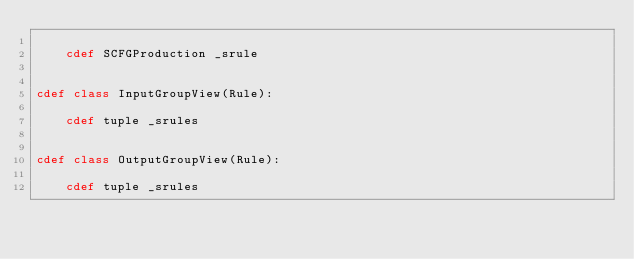Convert code to text. <code><loc_0><loc_0><loc_500><loc_500><_Cython_>
    cdef SCFGProduction _srule


cdef class InputGroupView(Rule):

    cdef tuple _srules


cdef class OutputGroupView(Rule):

    cdef tuple _srules
</code> 